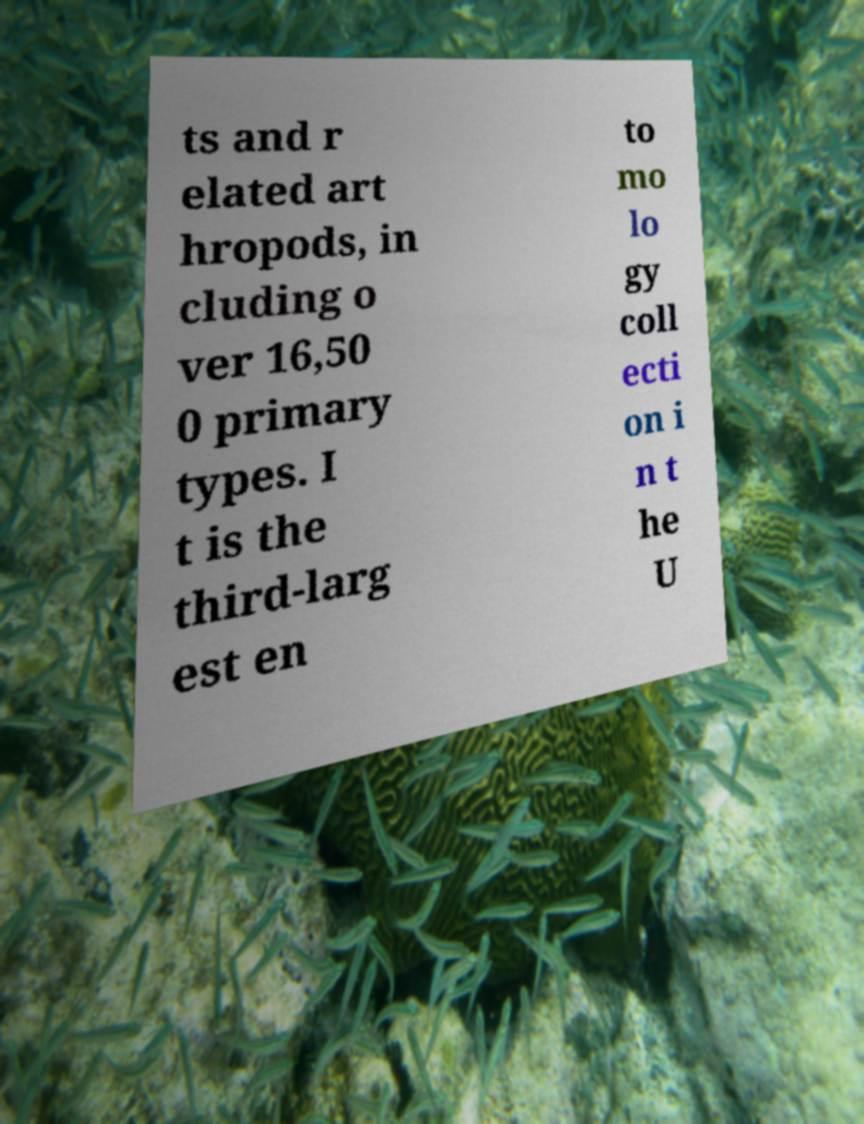Please identify and transcribe the text found in this image. ts and r elated art hropods, in cluding o ver 16,50 0 primary types. I t is the third-larg est en to mo lo gy coll ecti on i n t he U 